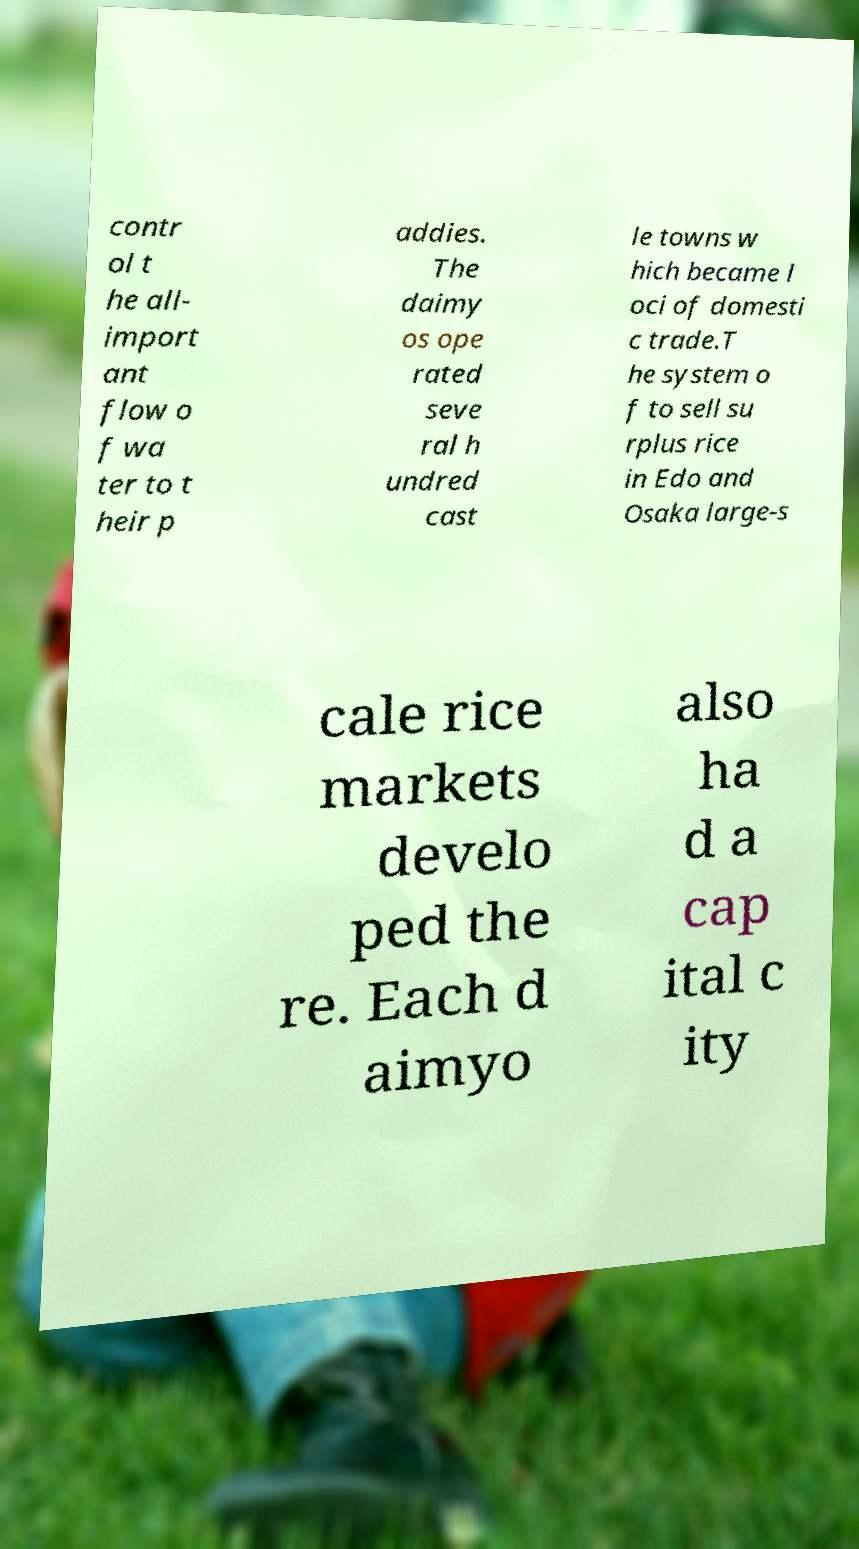There's text embedded in this image that I need extracted. Can you transcribe it verbatim? contr ol t he all- import ant flow o f wa ter to t heir p addies. The daimy os ope rated seve ral h undred cast le towns w hich became l oci of domesti c trade.T he system o f to sell su rplus rice in Edo and Osaka large-s cale rice markets develo ped the re. Each d aimyo also ha d a cap ital c ity 